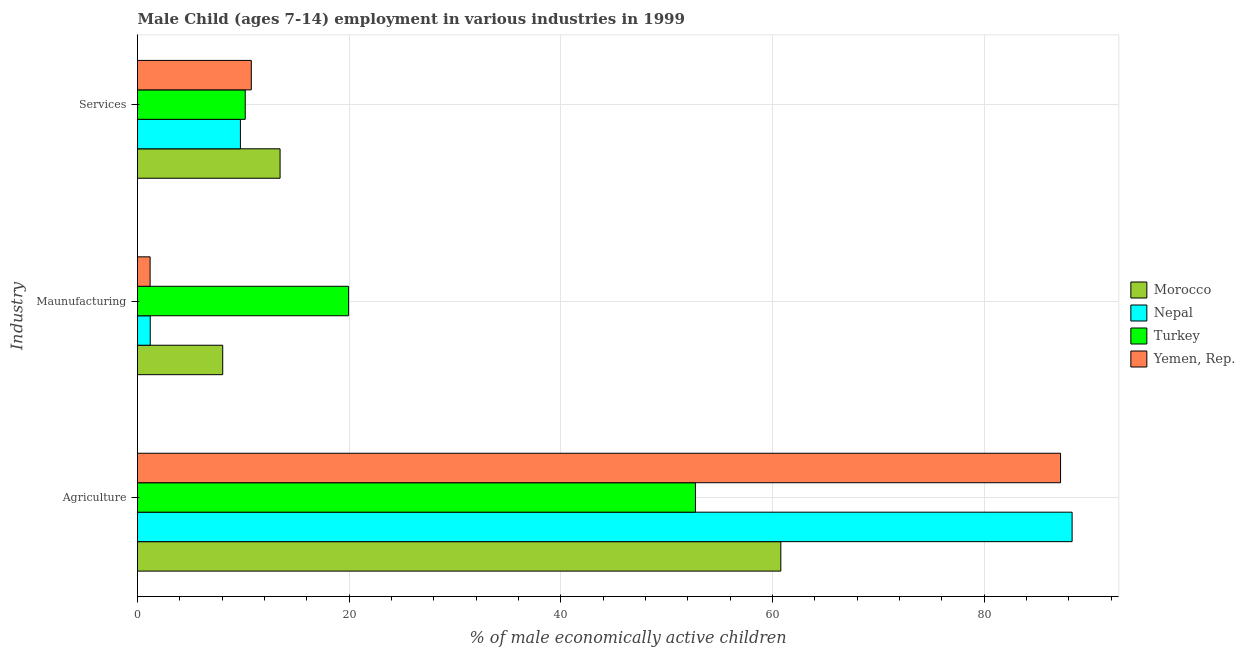How many different coloured bars are there?
Make the answer very short. 4. How many groups of bars are there?
Provide a succinct answer. 3. Are the number of bars on each tick of the Y-axis equal?
Make the answer very short. Yes. How many bars are there on the 1st tick from the top?
Your response must be concise. 4. What is the label of the 3rd group of bars from the top?
Your answer should be compact. Agriculture. What is the percentage of economically active children in services in Turkey?
Your answer should be compact. 10.18. Across all countries, what is the maximum percentage of economically active children in manufacturing?
Offer a very short reply. 19.94. Across all countries, what is the minimum percentage of economically active children in manufacturing?
Your answer should be compact. 1.19. In which country was the percentage of economically active children in manufacturing maximum?
Offer a terse response. Turkey. What is the total percentage of economically active children in manufacturing in the graph?
Your response must be concise. 30.39. What is the difference between the percentage of economically active children in services in Nepal and that in Turkey?
Make the answer very short. -0.45. What is the difference between the percentage of economically active children in services in Turkey and the percentage of economically active children in agriculture in Nepal?
Give a very brief answer. -78.12. What is the average percentage of economically active children in manufacturing per country?
Offer a very short reply. 7.6. What is the difference between the percentage of economically active children in manufacturing and percentage of economically active children in agriculture in Morocco?
Your response must be concise. -52.73. What is the ratio of the percentage of economically active children in manufacturing in Turkey to that in Morocco?
Your answer should be compact. 2.48. Is the percentage of economically active children in manufacturing in Nepal less than that in Turkey?
Make the answer very short. Yes. What is the difference between the highest and the second highest percentage of economically active children in services?
Offer a terse response. 2.72. What is the difference between the highest and the lowest percentage of economically active children in services?
Provide a succinct answer. 3.75. What does the 1st bar from the top in Agriculture represents?
Your answer should be compact. Yemen, Rep. What does the 4th bar from the bottom in Services represents?
Offer a very short reply. Yemen, Rep. Is it the case that in every country, the sum of the percentage of economically active children in agriculture and percentage of economically active children in manufacturing is greater than the percentage of economically active children in services?
Offer a very short reply. Yes. What is the difference between two consecutive major ticks on the X-axis?
Give a very brief answer. 20. Are the values on the major ticks of X-axis written in scientific E-notation?
Give a very brief answer. No. Does the graph contain any zero values?
Ensure brevity in your answer.  No. Does the graph contain grids?
Offer a very short reply. Yes. Where does the legend appear in the graph?
Your answer should be compact. Center right. How many legend labels are there?
Provide a short and direct response. 4. How are the legend labels stacked?
Provide a succinct answer. Vertical. What is the title of the graph?
Provide a short and direct response. Male Child (ages 7-14) employment in various industries in 1999. Does "Iran" appear as one of the legend labels in the graph?
Offer a terse response. No. What is the label or title of the X-axis?
Give a very brief answer. % of male economically active children. What is the label or title of the Y-axis?
Offer a very short reply. Industry. What is the % of male economically active children in Morocco in Agriculture?
Your answer should be compact. 60.78. What is the % of male economically active children in Nepal in Agriculture?
Offer a very short reply. 88.3. What is the % of male economically active children in Turkey in Agriculture?
Ensure brevity in your answer.  52.71. What is the % of male economically active children of Yemen, Rep. in Agriculture?
Your response must be concise. 87.21. What is the % of male economically active children in Morocco in Maunufacturing?
Your response must be concise. 8.05. What is the % of male economically active children in Nepal in Maunufacturing?
Ensure brevity in your answer.  1.2. What is the % of male economically active children of Turkey in Maunufacturing?
Provide a short and direct response. 19.94. What is the % of male economically active children in Yemen, Rep. in Maunufacturing?
Make the answer very short. 1.19. What is the % of male economically active children of Morocco in Services?
Your answer should be compact. 13.47. What is the % of male economically active children in Nepal in Services?
Offer a terse response. 9.72. What is the % of male economically active children in Turkey in Services?
Keep it short and to the point. 10.18. What is the % of male economically active children of Yemen, Rep. in Services?
Make the answer very short. 10.75. Across all Industry, what is the maximum % of male economically active children of Morocco?
Give a very brief answer. 60.78. Across all Industry, what is the maximum % of male economically active children of Nepal?
Your answer should be compact. 88.3. Across all Industry, what is the maximum % of male economically active children of Turkey?
Your response must be concise. 52.71. Across all Industry, what is the maximum % of male economically active children of Yemen, Rep.?
Keep it short and to the point. 87.21. Across all Industry, what is the minimum % of male economically active children in Morocco?
Your answer should be very brief. 8.05. Across all Industry, what is the minimum % of male economically active children of Nepal?
Your answer should be very brief. 1.2. Across all Industry, what is the minimum % of male economically active children in Turkey?
Your answer should be compact. 10.18. Across all Industry, what is the minimum % of male economically active children of Yemen, Rep.?
Offer a terse response. 1.19. What is the total % of male economically active children of Morocco in the graph?
Provide a short and direct response. 82.3. What is the total % of male economically active children in Nepal in the graph?
Provide a succinct answer. 99.23. What is the total % of male economically active children of Turkey in the graph?
Make the answer very short. 82.83. What is the total % of male economically active children of Yemen, Rep. in the graph?
Your response must be concise. 99.15. What is the difference between the % of male economically active children in Morocco in Agriculture and that in Maunufacturing?
Provide a short and direct response. 52.73. What is the difference between the % of male economically active children of Nepal in Agriculture and that in Maunufacturing?
Your response must be concise. 87.1. What is the difference between the % of male economically active children of Turkey in Agriculture and that in Maunufacturing?
Provide a succinct answer. 32.77. What is the difference between the % of male economically active children in Yemen, Rep. in Agriculture and that in Maunufacturing?
Offer a terse response. 86.02. What is the difference between the % of male economically active children in Morocco in Agriculture and that in Services?
Provide a short and direct response. 47.31. What is the difference between the % of male economically active children of Nepal in Agriculture and that in Services?
Ensure brevity in your answer.  78.58. What is the difference between the % of male economically active children of Turkey in Agriculture and that in Services?
Give a very brief answer. 42.53. What is the difference between the % of male economically active children of Yemen, Rep. in Agriculture and that in Services?
Your answer should be compact. 76.46. What is the difference between the % of male economically active children of Morocco in Maunufacturing and that in Services?
Provide a succinct answer. -5.42. What is the difference between the % of male economically active children in Nepal in Maunufacturing and that in Services?
Your response must be concise. -8.52. What is the difference between the % of male economically active children of Turkey in Maunufacturing and that in Services?
Give a very brief answer. 9.77. What is the difference between the % of male economically active children of Yemen, Rep. in Maunufacturing and that in Services?
Your response must be concise. -9.56. What is the difference between the % of male economically active children of Morocco in Agriculture and the % of male economically active children of Nepal in Maunufacturing?
Keep it short and to the point. 59.58. What is the difference between the % of male economically active children in Morocco in Agriculture and the % of male economically active children in Turkey in Maunufacturing?
Give a very brief answer. 40.84. What is the difference between the % of male economically active children in Morocco in Agriculture and the % of male economically active children in Yemen, Rep. in Maunufacturing?
Make the answer very short. 59.59. What is the difference between the % of male economically active children of Nepal in Agriculture and the % of male economically active children of Turkey in Maunufacturing?
Offer a very short reply. 68.36. What is the difference between the % of male economically active children of Nepal in Agriculture and the % of male economically active children of Yemen, Rep. in Maunufacturing?
Offer a terse response. 87.11. What is the difference between the % of male economically active children in Turkey in Agriculture and the % of male economically active children in Yemen, Rep. in Maunufacturing?
Keep it short and to the point. 51.52. What is the difference between the % of male economically active children of Morocco in Agriculture and the % of male economically active children of Nepal in Services?
Keep it short and to the point. 51.06. What is the difference between the % of male economically active children in Morocco in Agriculture and the % of male economically active children in Turkey in Services?
Offer a terse response. 50.6. What is the difference between the % of male economically active children in Morocco in Agriculture and the % of male economically active children in Yemen, Rep. in Services?
Your answer should be compact. 50.03. What is the difference between the % of male economically active children of Nepal in Agriculture and the % of male economically active children of Turkey in Services?
Keep it short and to the point. 78.12. What is the difference between the % of male economically active children of Nepal in Agriculture and the % of male economically active children of Yemen, Rep. in Services?
Keep it short and to the point. 77.55. What is the difference between the % of male economically active children in Turkey in Agriculture and the % of male economically active children in Yemen, Rep. in Services?
Provide a short and direct response. 41.96. What is the difference between the % of male economically active children in Morocco in Maunufacturing and the % of male economically active children in Nepal in Services?
Provide a short and direct response. -1.67. What is the difference between the % of male economically active children of Morocco in Maunufacturing and the % of male economically active children of Turkey in Services?
Your answer should be very brief. -2.13. What is the difference between the % of male economically active children in Nepal in Maunufacturing and the % of male economically active children in Turkey in Services?
Provide a short and direct response. -8.97. What is the difference between the % of male economically active children of Nepal in Maunufacturing and the % of male economically active children of Yemen, Rep. in Services?
Provide a short and direct response. -9.55. What is the difference between the % of male economically active children of Turkey in Maunufacturing and the % of male economically active children of Yemen, Rep. in Services?
Your answer should be very brief. 9.19. What is the average % of male economically active children in Morocco per Industry?
Your answer should be very brief. 27.43. What is the average % of male economically active children in Nepal per Industry?
Provide a succinct answer. 33.08. What is the average % of male economically active children of Turkey per Industry?
Keep it short and to the point. 27.61. What is the average % of male economically active children of Yemen, Rep. per Industry?
Your answer should be very brief. 33.05. What is the difference between the % of male economically active children in Morocco and % of male economically active children in Nepal in Agriculture?
Give a very brief answer. -27.52. What is the difference between the % of male economically active children in Morocco and % of male economically active children in Turkey in Agriculture?
Provide a succinct answer. 8.07. What is the difference between the % of male economically active children in Morocco and % of male economically active children in Yemen, Rep. in Agriculture?
Give a very brief answer. -26.43. What is the difference between the % of male economically active children of Nepal and % of male economically active children of Turkey in Agriculture?
Ensure brevity in your answer.  35.59. What is the difference between the % of male economically active children of Nepal and % of male economically active children of Yemen, Rep. in Agriculture?
Give a very brief answer. 1.09. What is the difference between the % of male economically active children in Turkey and % of male economically active children in Yemen, Rep. in Agriculture?
Offer a terse response. -34.5. What is the difference between the % of male economically active children of Morocco and % of male economically active children of Nepal in Maunufacturing?
Give a very brief answer. 6.85. What is the difference between the % of male economically active children of Morocco and % of male economically active children of Turkey in Maunufacturing?
Offer a very short reply. -11.89. What is the difference between the % of male economically active children of Morocco and % of male economically active children of Yemen, Rep. in Maunufacturing?
Keep it short and to the point. 6.86. What is the difference between the % of male economically active children of Nepal and % of male economically active children of Turkey in Maunufacturing?
Offer a terse response. -18.74. What is the difference between the % of male economically active children in Nepal and % of male economically active children in Yemen, Rep. in Maunufacturing?
Your answer should be very brief. 0.01. What is the difference between the % of male economically active children in Turkey and % of male economically active children in Yemen, Rep. in Maunufacturing?
Give a very brief answer. 18.75. What is the difference between the % of male economically active children of Morocco and % of male economically active children of Nepal in Services?
Your response must be concise. 3.75. What is the difference between the % of male economically active children in Morocco and % of male economically active children in Turkey in Services?
Your response must be concise. 3.29. What is the difference between the % of male economically active children of Morocco and % of male economically active children of Yemen, Rep. in Services?
Offer a terse response. 2.72. What is the difference between the % of male economically active children of Nepal and % of male economically active children of Turkey in Services?
Provide a short and direct response. -0.45. What is the difference between the % of male economically active children in Nepal and % of male economically active children in Yemen, Rep. in Services?
Give a very brief answer. -1.03. What is the difference between the % of male economically active children in Turkey and % of male economically active children in Yemen, Rep. in Services?
Offer a very short reply. -0.57. What is the ratio of the % of male economically active children in Morocco in Agriculture to that in Maunufacturing?
Offer a terse response. 7.55. What is the ratio of the % of male economically active children in Nepal in Agriculture to that in Maunufacturing?
Offer a terse response. 73.36. What is the ratio of the % of male economically active children of Turkey in Agriculture to that in Maunufacturing?
Provide a short and direct response. 2.64. What is the ratio of the % of male economically active children in Yemen, Rep. in Agriculture to that in Maunufacturing?
Your answer should be very brief. 73.29. What is the ratio of the % of male economically active children of Morocco in Agriculture to that in Services?
Keep it short and to the point. 4.51. What is the ratio of the % of male economically active children in Nepal in Agriculture to that in Services?
Offer a terse response. 9.08. What is the ratio of the % of male economically active children of Turkey in Agriculture to that in Services?
Your answer should be very brief. 5.18. What is the ratio of the % of male economically active children of Yemen, Rep. in Agriculture to that in Services?
Offer a very short reply. 8.11. What is the ratio of the % of male economically active children in Morocco in Maunufacturing to that in Services?
Your answer should be compact. 0.6. What is the ratio of the % of male economically active children in Nepal in Maunufacturing to that in Services?
Keep it short and to the point. 0.12. What is the ratio of the % of male economically active children of Turkey in Maunufacturing to that in Services?
Offer a very short reply. 1.96. What is the ratio of the % of male economically active children of Yemen, Rep. in Maunufacturing to that in Services?
Offer a terse response. 0.11. What is the difference between the highest and the second highest % of male economically active children in Morocco?
Your answer should be compact. 47.31. What is the difference between the highest and the second highest % of male economically active children of Nepal?
Keep it short and to the point. 78.58. What is the difference between the highest and the second highest % of male economically active children in Turkey?
Make the answer very short. 32.77. What is the difference between the highest and the second highest % of male economically active children of Yemen, Rep.?
Give a very brief answer. 76.46. What is the difference between the highest and the lowest % of male economically active children of Morocco?
Your answer should be compact. 52.73. What is the difference between the highest and the lowest % of male economically active children of Nepal?
Offer a terse response. 87.1. What is the difference between the highest and the lowest % of male economically active children of Turkey?
Offer a very short reply. 42.53. What is the difference between the highest and the lowest % of male economically active children of Yemen, Rep.?
Your answer should be compact. 86.02. 